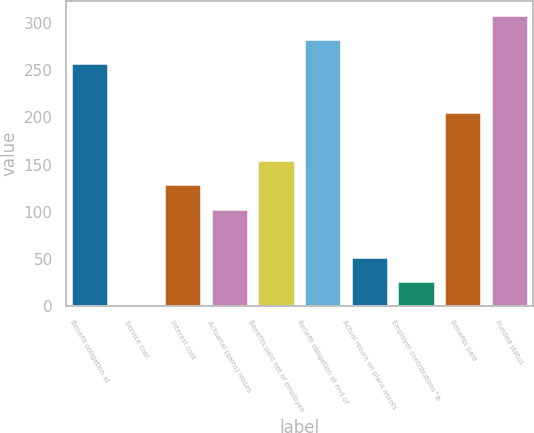Convert chart. <chart><loc_0><loc_0><loc_500><loc_500><bar_chart><fcel>Benefit obligation at<fcel>Service cost<fcel>Interest cost<fcel>Actuarial (gains) losses<fcel>Benefits paid net of employee<fcel>Benefit obligation at end of<fcel>Actual return on plans assets<fcel>Employer contributions^b<fcel>Benefits paid<fcel>Funded status<nl><fcel>257<fcel>1<fcel>129<fcel>103.4<fcel>154.6<fcel>282.6<fcel>52.2<fcel>26.6<fcel>205.8<fcel>308.2<nl></chart> 